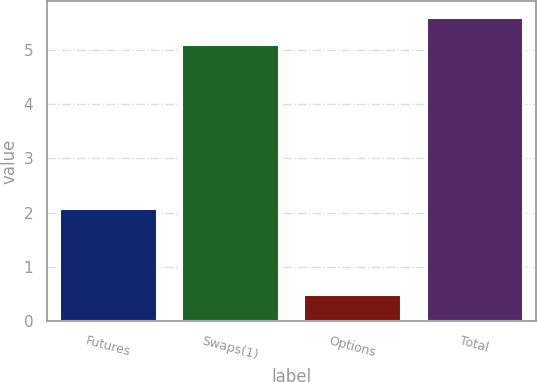Convert chart. <chart><loc_0><loc_0><loc_500><loc_500><bar_chart><fcel>Futures<fcel>Swaps(1)<fcel>Options<fcel>Total<nl><fcel>2.09<fcel>5.1<fcel>0.5<fcel>5.61<nl></chart> 